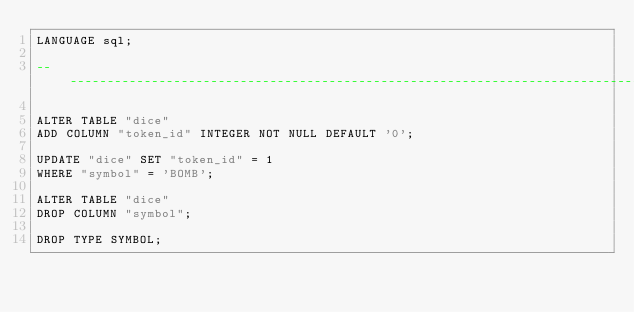<code> <loc_0><loc_0><loc_500><loc_500><_SQL_>LANGUAGE sql;

--------------------------------------------------------------------------------

ALTER TABLE "dice"
ADD COLUMN "token_id" INTEGER NOT NULL DEFAULT '0';

UPDATE "dice" SET "token_id" = 1
WHERE "symbol" = 'BOMB';

ALTER TABLE "dice"
DROP COLUMN "symbol";

DROP TYPE SYMBOL;
</code> 